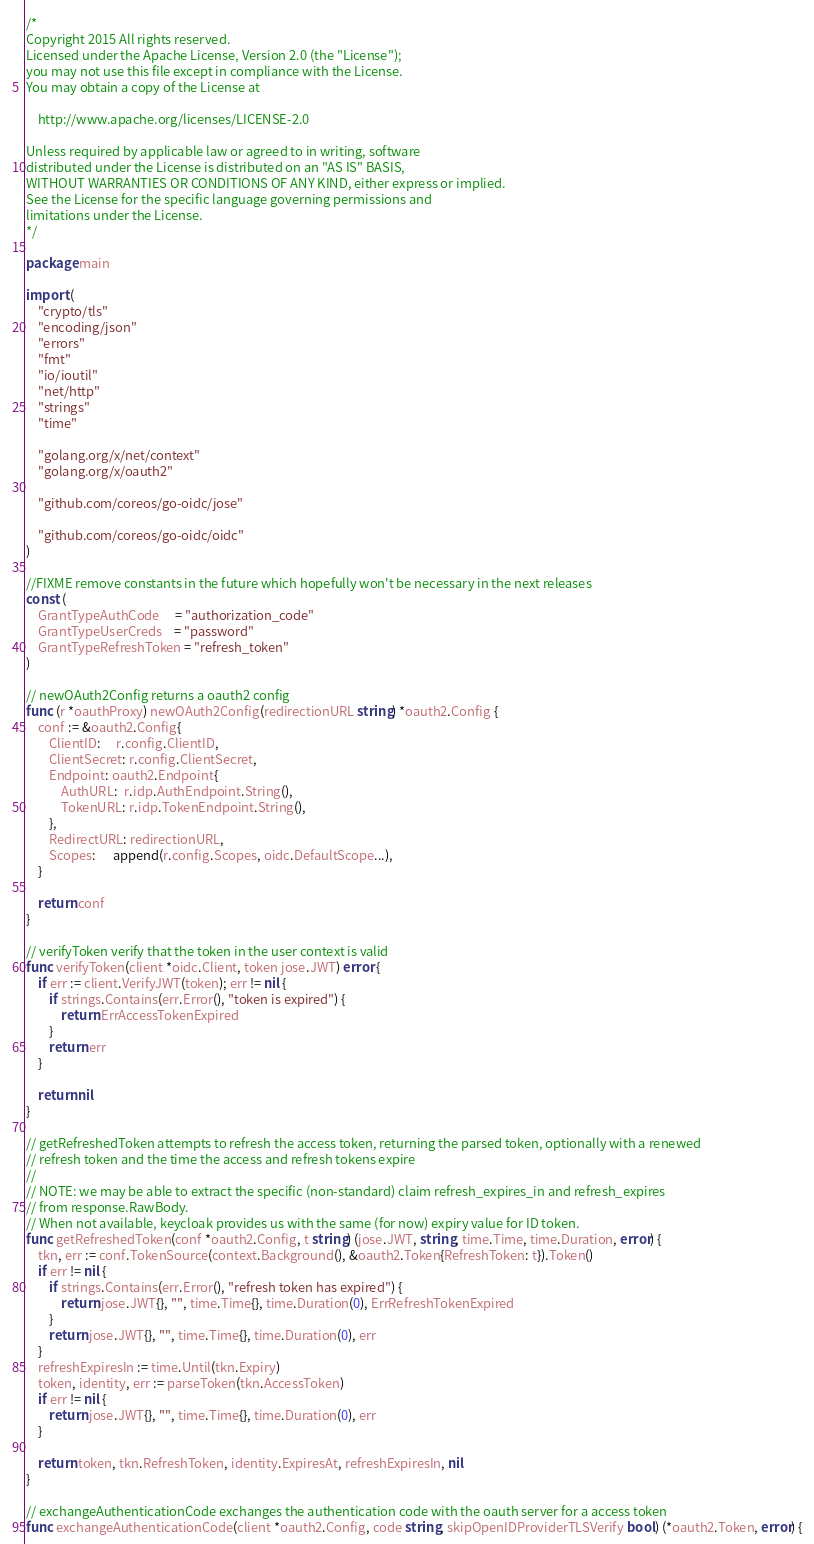Convert code to text. <code><loc_0><loc_0><loc_500><loc_500><_Go_>/*
Copyright 2015 All rights reserved.
Licensed under the Apache License, Version 2.0 (the "License");
you may not use this file except in compliance with the License.
You may obtain a copy of the License at

    http://www.apache.org/licenses/LICENSE-2.0

Unless required by applicable law or agreed to in writing, software
distributed under the License is distributed on an "AS IS" BASIS,
WITHOUT WARRANTIES OR CONDITIONS OF ANY KIND, either express or implied.
See the License for the specific language governing permissions and
limitations under the License.
*/

package main

import (
	"crypto/tls"
	"encoding/json"
	"errors"
	"fmt"
	"io/ioutil"
	"net/http"
	"strings"
	"time"

	"golang.org/x/net/context"
	"golang.org/x/oauth2"

	"github.com/coreos/go-oidc/jose"

	"github.com/coreos/go-oidc/oidc"
)

//FIXME remove constants in the future which hopefully won't be necessary in the next releases
const (
	GrantTypeAuthCode     = "authorization_code"
	GrantTypeUserCreds    = "password"
	GrantTypeRefreshToken = "refresh_token"
)

// newOAuth2Config returns a oauth2 config
func (r *oauthProxy) newOAuth2Config(redirectionURL string) *oauth2.Config {
	conf := &oauth2.Config{
		ClientID:     r.config.ClientID,
		ClientSecret: r.config.ClientSecret,
		Endpoint: oauth2.Endpoint{
			AuthURL:  r.idp.AuthEndpoint.String(),
			TokenURL: r.idp.TokenEndpoint.String(),
		},
		RedirectURL: redirectionURL,
		Scopes:      append(r.config.Scopes, oidc.DefaultScope...),
	}

	return conf
}

// verifyToken verify that the token in the user context is valid
func verifyToken(client *oidc.Client, token jose.JWT) error {
	if err := client.VerifyJWT(token); err != nil {
		if strings.Contains(err.Error(), "token is expired") {
			return ErrAccessTokenExpired
		}
		return err
	}

	return nil
}

// getRefreshedToken attempts to refresh the access token, returning the parsed token, optionally with a renewed
// refresh token and the time the access and refresh tokens expire
//
// NOTE: we may be able to extract the specific (non-standard) claim refresh_expires_in and refresh_expires
// from response.RawBody.
// When not available, keycloak provides us with the same (for now) expiry value for ID token.
func getRefreshedToken(conf *oauth2.Config, t string) (jose.JWT, string, time.Time, time.Duration, error) {
	tkn, err := conf.TokenSource(context.Background(), &oauth2.Token{RefreshToken: t}).Token()
	if err != nil {
		if strings.Contains(err.Error(), "refresh token has expired") {
			return jose.JWT{}, "", time.Time{}, time.Duration(0), ErrRefreshTokenExpired
		}
		return jose.JWT{}, "", time.Time{}, time.Duration(0), err
	}
	refreshExpiresIn := time.Until(tkn.Expiry)
	token, identity, err := parseToken(tkn.AccessToken)
	if err != nil {
		return jose.JWT{}, "", time.Time{}, time.Duration(0), err
	}

	return token, tkn.RefreshToken, identity.ExpiresAt, refreshExpiresIn, nil
}

// exchangeAuthenticationCode exchanges the authentication code with the oauth server for a access token
func exchangeAuthenticationCode(client *oauth2.Config, code string, skipOpenIDProviderTLSVerify bool) (*oauth2.Token, error) {</code> 